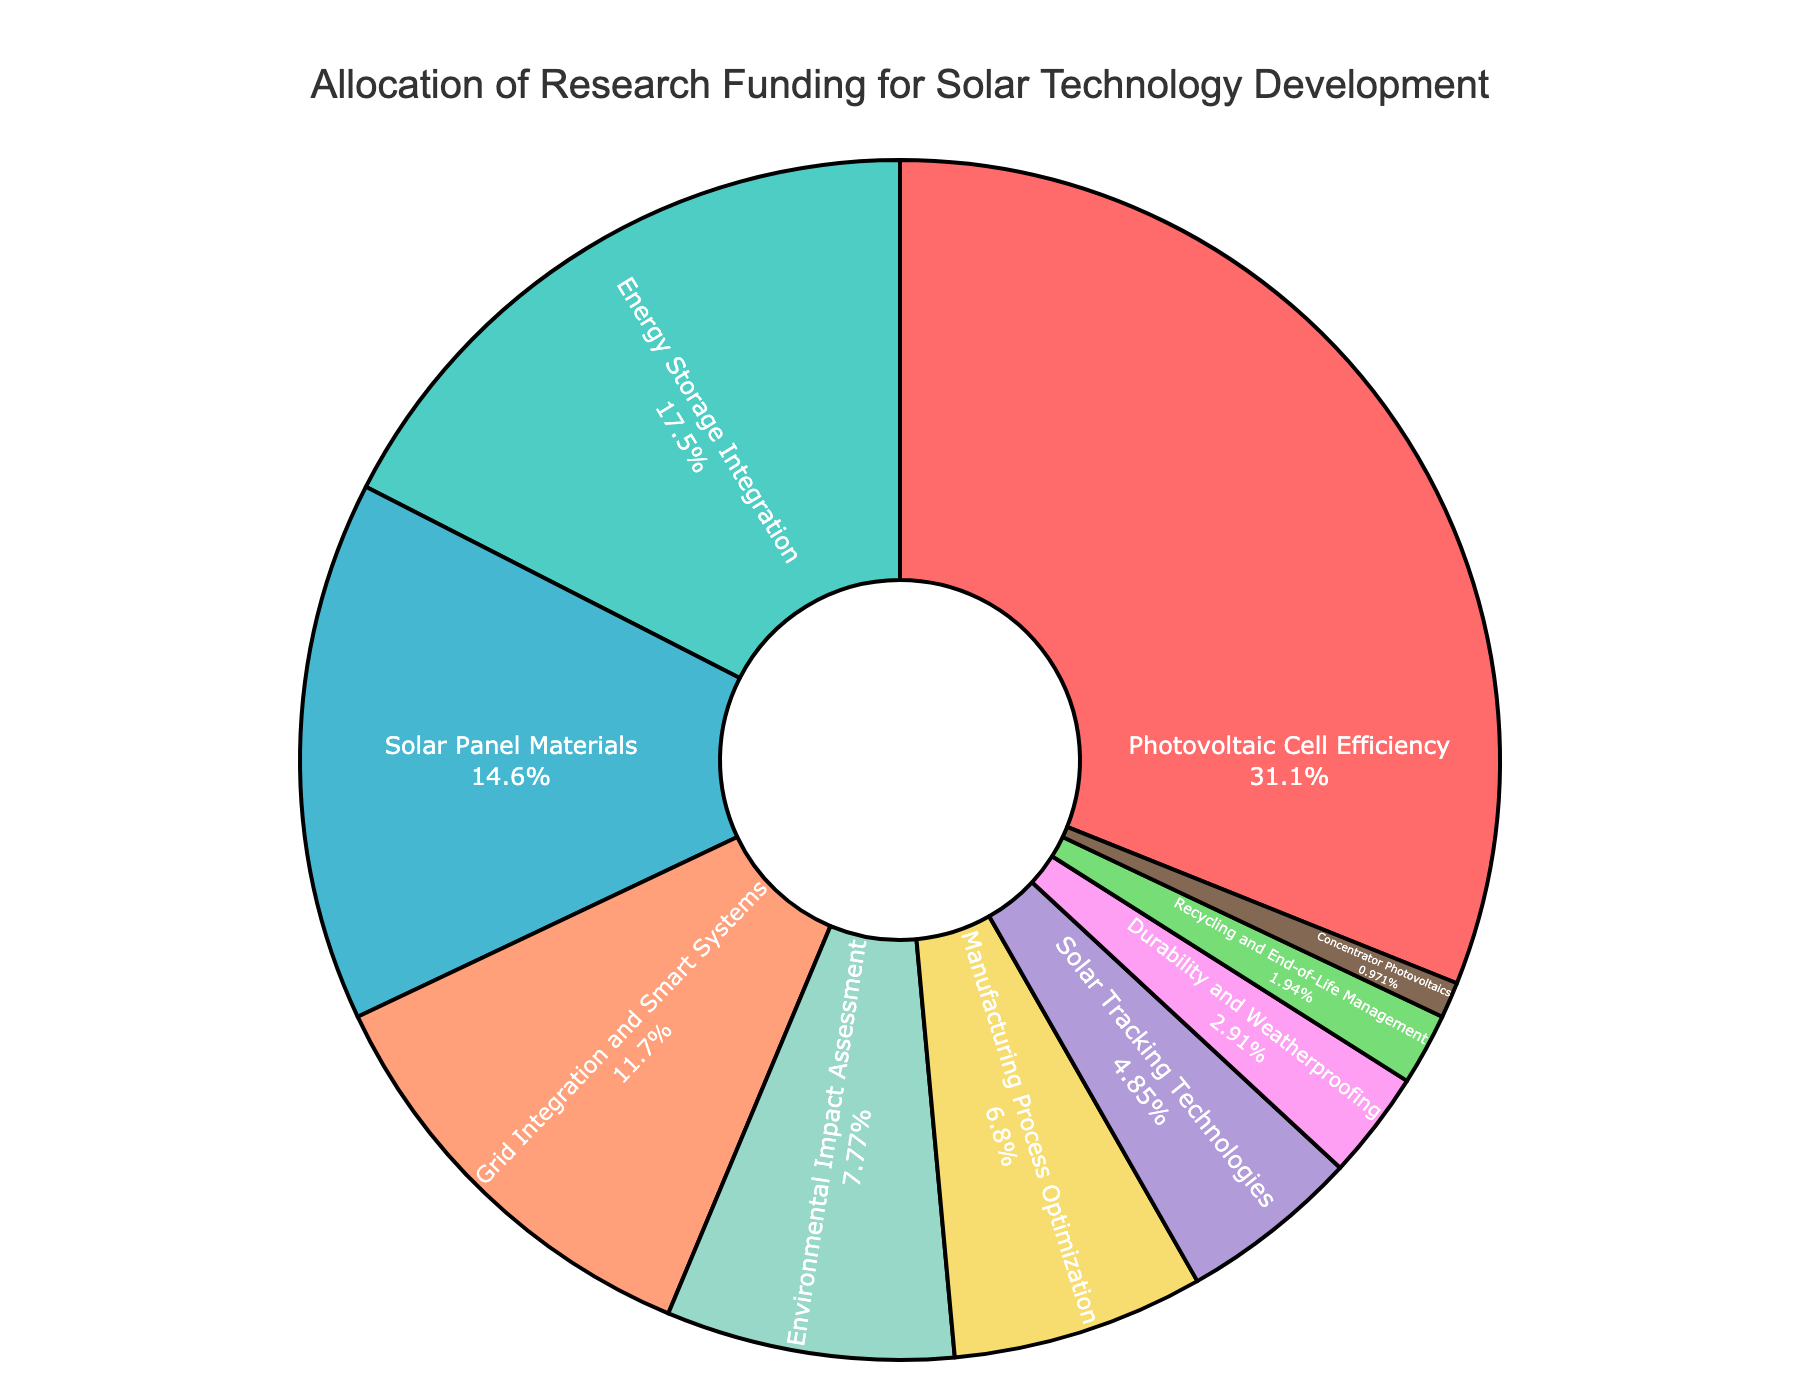Which research area received the most funding? The segment labeled "Photovoltaic Cell Efficiency" is the largest portion of the pie chart.
Answer: Photovoltaic Cell Efficiency What percentage of the funding is allocated to Energy Storage Integration and Grid Integration and Smart Systems combined? The pie chart shows Energy Storage Integration at 18% and Grid Integration and Smart Systems at 12%. Summing these gives 18% + 12% = 30%.
Answer: 30% How many percentage points lower is the funding for Recycling and End-of-Life Management compared to Solar Panel Materials? The chart shows Solar Panel Materials at 15% and Recycling and End-of-Life Management at 2%. The difference is 15% - 2% = 13%.
Answer: 13% Which two areas received the least funding? The slices of the pie chart with the smallest sizes represent "Concentrator Photovoltaics" and "Recycling and End-of-Life Management".
Answer: Concentrator Photovoltaics and Recycling and End-of-Life Management Is the funding for Environmental Impact Assessment more or less than Energy Storage Integration? The pie chart shows Environmental Impact Assessment at 8% and Energy Storage Integration at 18%, thus Environmental Impact Assessment receives less funding.
Answer: Less What's the total funding percentage allocated to Solar Tracking Technologies, Durability and Weatherproofing, and Manufacturing Process Optimization? The pie chart shows Solar Tracking Technologies at 5%, Durability and Weatherproofing at 3%, and Manufacturing Process Optimization at 7%. Summing these gives 5% + 3% + 7% = 15%.
Answer: 15% What is the color representation for Photovoltaic Cell Efficiency in the chart? The segment marked "Photovoltaic Cell Efficiency" is colored red.
Answer: Red Compare the funding between Solar Panel Materials and Grid Integration and Smart Systems. Which received more and by how much? Solar Panel Materials received 15% and Grid Integration and Smart Systems received 12%, hence Solar Panel Materials received 15% - 12% = 3% more funding.
Answer: Solar Panel Materials by 3% What is the smallest funding allocation and its corresponding research area? The smallest segment in the pie chart represents "Concentrator Photovoltaics" with 1% funding.
Answer: 1% for Concentrator Photovoltaics 